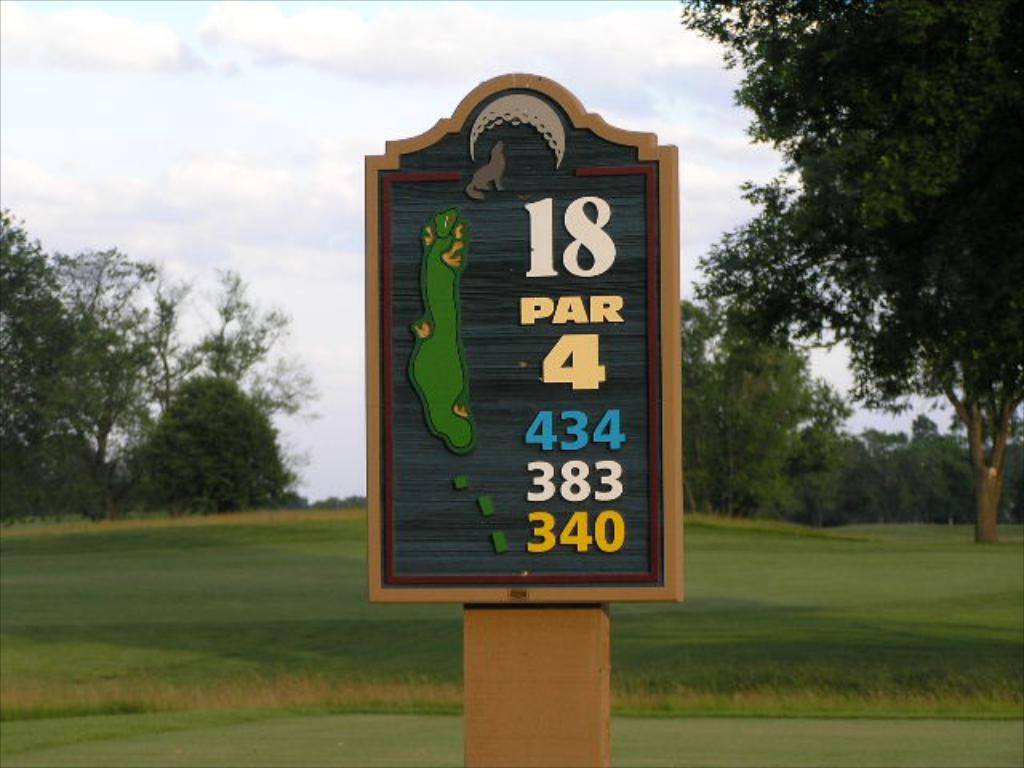<image>
Describe the image concisely. The name board  has wolf and moon structure with  writings as 18 PAR 4 434 383 340 